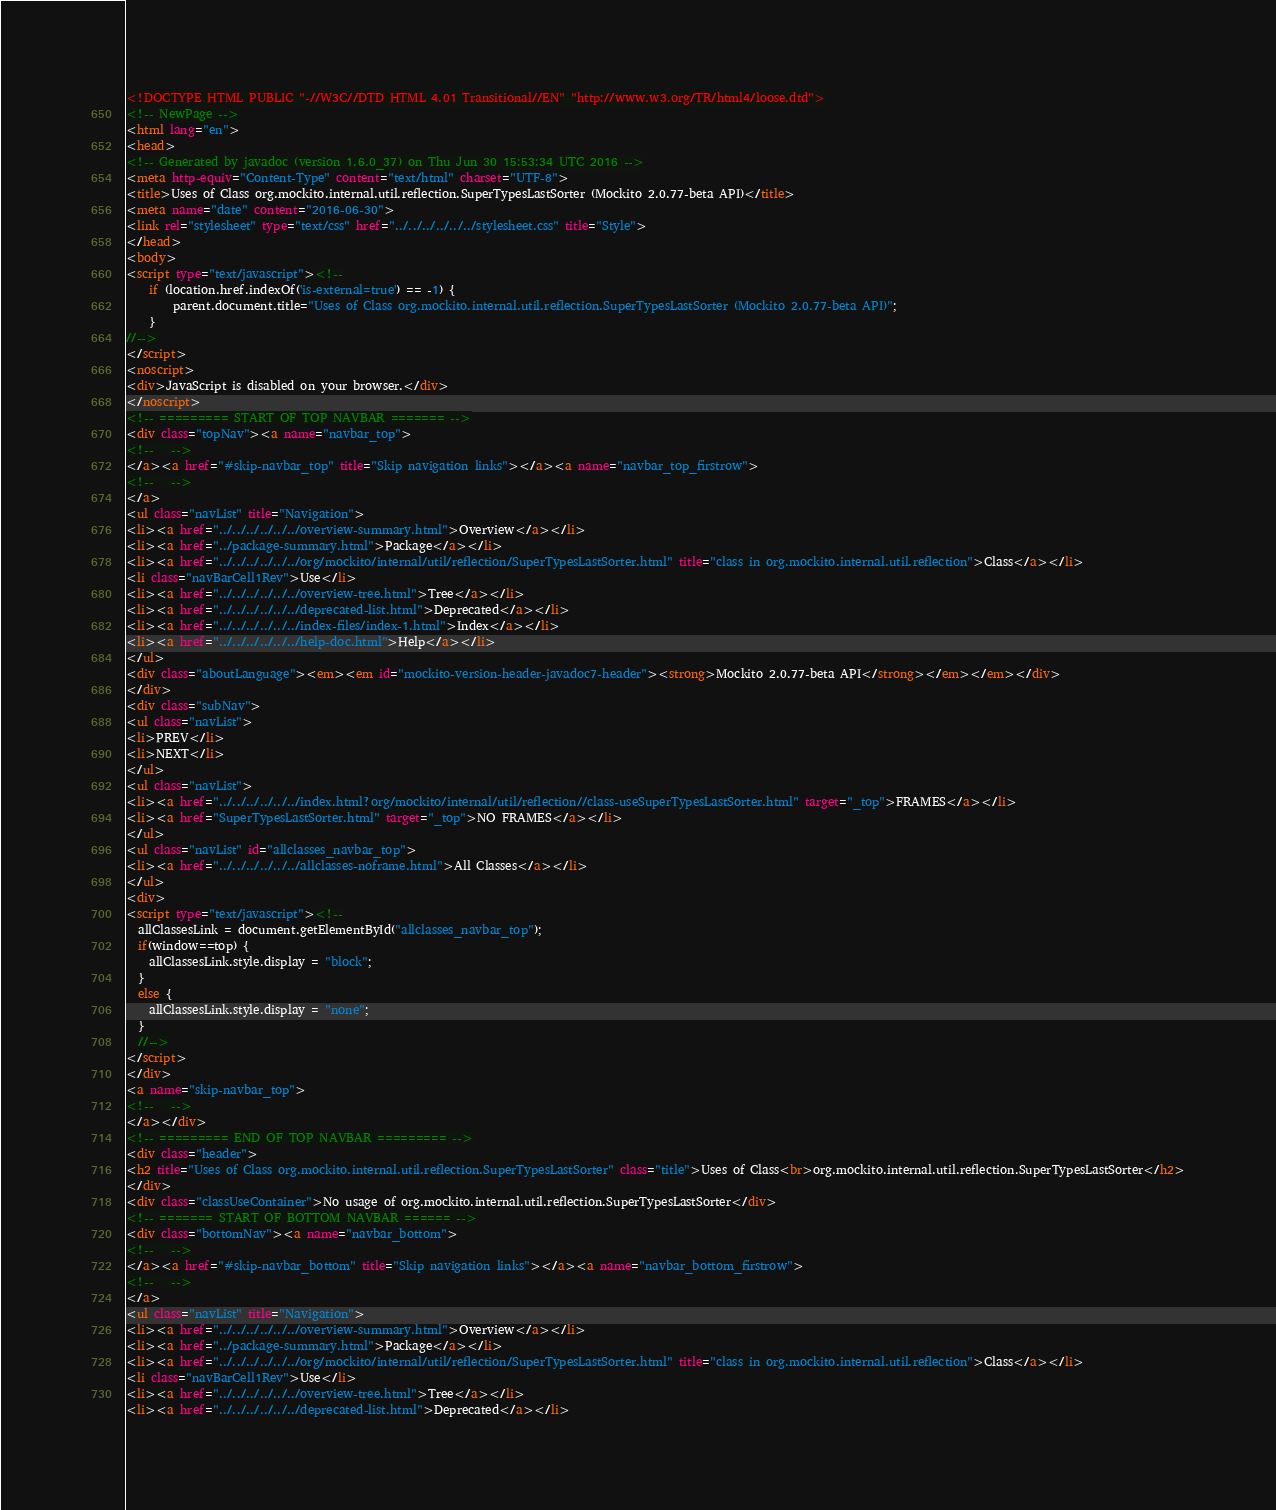<code> <loc_0><loc_0><loc_500><loc_500><_HTML_><!DOCTYPE HTML PUBLIC "-//W3C//DTD HTML 4.01 Transitional//EN" "http://www.w3.org/TR/html4/loose.dtd">
<!-- NewPage -->
<html lang="en">
<head>
<!-- Generated by javadoc (version 1.6.0_37) on Thu Jun 30 15:53:34 UTC 2016 -->
<meta http-equiv="Content-Type" content="text/html" charset="UTF-8">
<title>Uses of Class org.mockito.internal.util.reflection.SuperTypesLastSorter (Mockito 2.0.77-beta API)</title>
<meta name="date" content="2016-06-30">
<link rel="stylesheet" type="text/css" href="../../../../../../stylesheet.css" title="Style">
</head>
<body>
<script type="text/javascript"><!--
    if (location.href.indexOf('is-external=true') == -1) {
        parent.document.title="Uses of Class org.mockito.internal.util.reflection.SuperTypesLastSorter (Mockito 2.0.77-beta API)";
    }
//-->
</script>
<noscript>
<div>JavaScript is disabled on your browser.</div>
</noscript>
<!-- ========= START OF TOP NAVBAR ======= -->
<div class="topNav"><a name="navbar_top">
<!--   -->
</a><a href="#skip-navbar_top" title="Skip navigation links"></a><a name="navbar_top_firstrow">
<!--   -->
</a>
<ul class="navList" title="Navigation">
<li><a href="../../../../../../overview-summary.html">Overview</a></li>
<li><a href="../package-summary.html">Package</a></li>
<li><a href="../../../../../../org/mockito/internal/util/reflection/SuperTypesLastSorter.html" title="class in org.mockito.internal.util.reflection">Class</a></li>
<li class="navBarCell1Rev">Use</li>
<li><a href="../../../../../../overview-tree.html">Tree</a></li>
<li><a href="../../../../../../deprecated-list.html">Deprecated</a></li>
<li><a href="../../../../../../index-files/index-1.html">Index</a></li>
<li><a href="../../../../../../help-doc.html">Help</a></li>
</ul>
<div class="aboutLanguage"><em><em id="mockito-version-header-javadoc7-header"><strong>Mockito 2.0.77-beta API</strong></em></em></div>
</div>
<div class="subNav">
<ul class="navList">
<li>PREV</li>
<li>NEXT</li>
</ul>
<ul class="navList">
<li><a href="../../../../../../index.html?org/mockito/internal/util/reflection//class-useSuperTypesLastSorter.html" target="_top">FRAMES</a></li>
<li><a href="SuperTypesLastSorter.html" target="_top">NO FRAMES</a></li>
</ul>
<ul class="navList" id="allclasses_navbar_top">
<li><a href="../../../../../../allclasses-noframe.html">All Classes</a></li>
</ul>
<div>
<script type="text/javascript"><!--
  allClassesLink = document.getElementById("allclasses_navbar_top");
  if(window==top) {
    allClassesLink.style.display = "block";
  }
  else {
    allClassesLink.style.display = "none";
  }
  //-->
</script>
</div>
<a name="skip-navbar_top">
<!--   -->
</a></div>
<!-- ========= END OF TOP NAVBAR ========= -->
<div class="header">
<h2 title="Uses of Class org.mockito.internal.util.reflection.SuperTypesLastSorter" class="title">Uses of Class<br>org.mockito.internal.util.reflection.SuperTypesLastSorter</h2>
</div>
<div class="classUseContainer">No usage of org.mockito.internal.util.reflection.SuperTypesLastSorter</div>
<!-- ======= START OF BOTTOM NAVBAR ====== -->
<div class="bottomNav"><a name="navbar_bottom">
<!--   -->
</a><a href="#skip-navbar_bottom" title="Skip navigation links"></a><a name="navbar_bottom_firstrow">
<!--   -->
</a>
<ul class="navList" title="Navigation">
<li><a href="../../../../../../overview-summary.html">Overview</a></li>
<li><a href="../package-summary.html">Package</a></li>
<li><a href="../../../../../../org/mockito/internal/util/reflection/SuperTypesLastSorter.html" title="class in org.mockito.internal.util.reflection">Class</a></li>
<li class="navBarCell1Rev">Use</li>
<li><a href="../../../../../../overview-tree.html">Tree</a></li>
<li><a href="../../../../../../deprecated-list.html">Deprecated</a></li></code> 